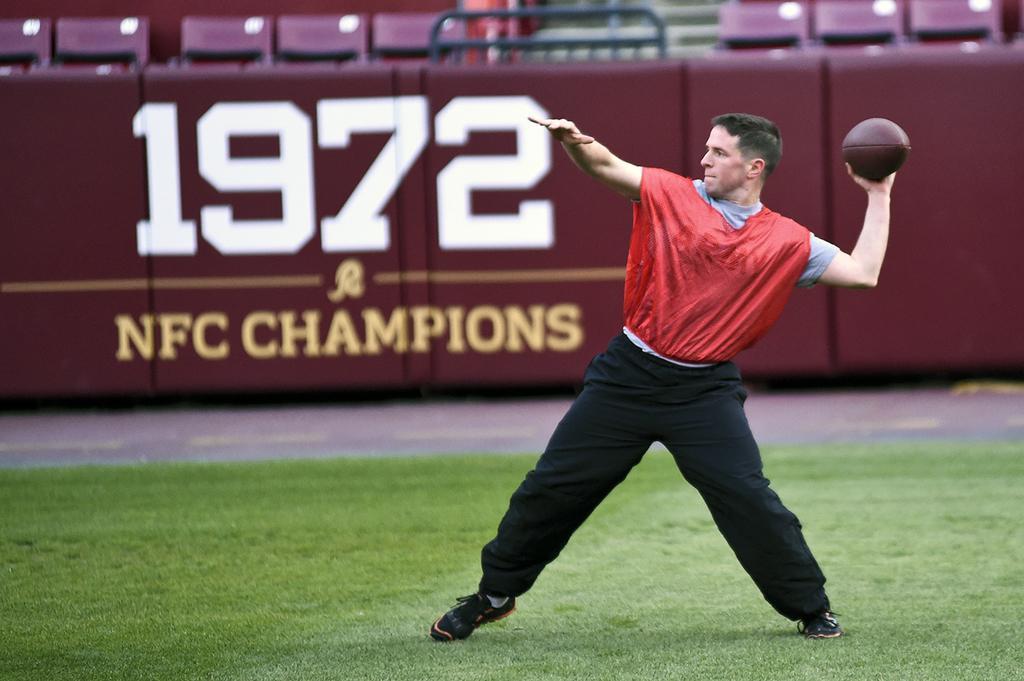In one or two sentences, can you explain what this image depicts? In this image, we can see a man standing on the grass, he is holding a rugby ball, in the background, we can see a wall and there are some chairs. 